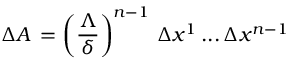<formula> <loc_0><loc_0><loc_500><loc_500>\, \Delta A \, = \left ( \frac { \Lambda } { \delta } \right ) ^ { n - 1 } \, \Delta x ^ { 1 } \, \dots \, \Delta x ^ { n - 1 } \,</formula> 